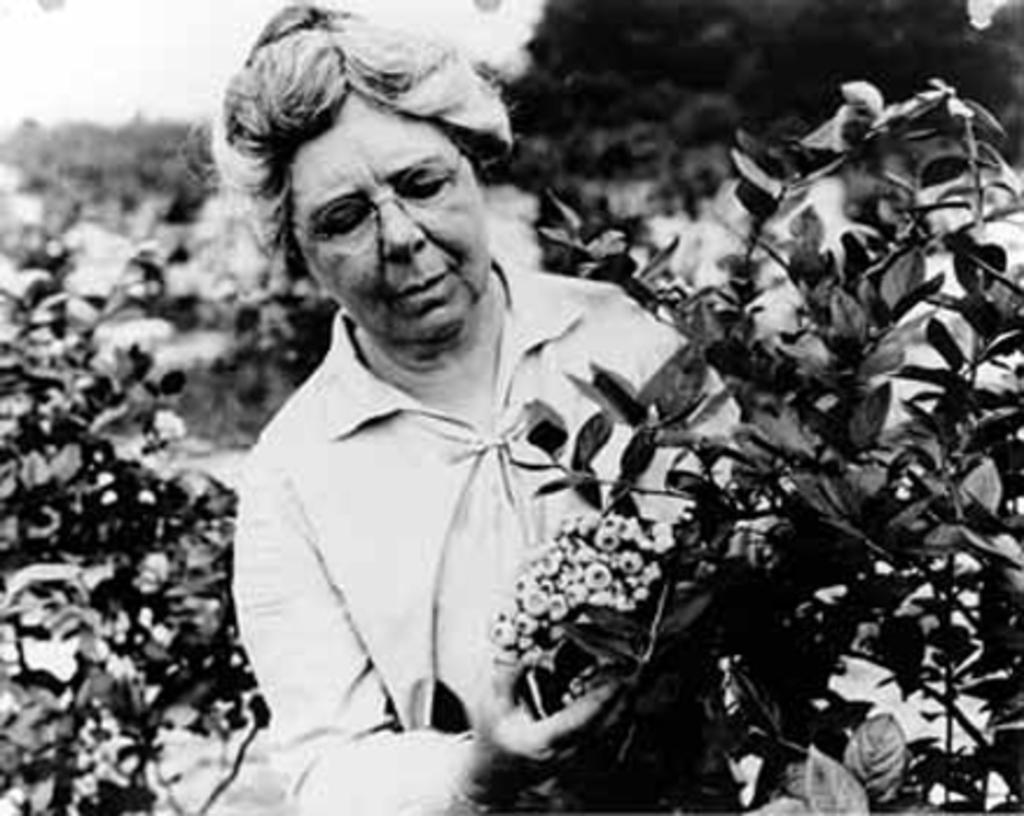Could you give a brief overview of what you see in this image? In this image in the center there is one woman who is standing and she is holding some flowers, and in the background there are some plants. 